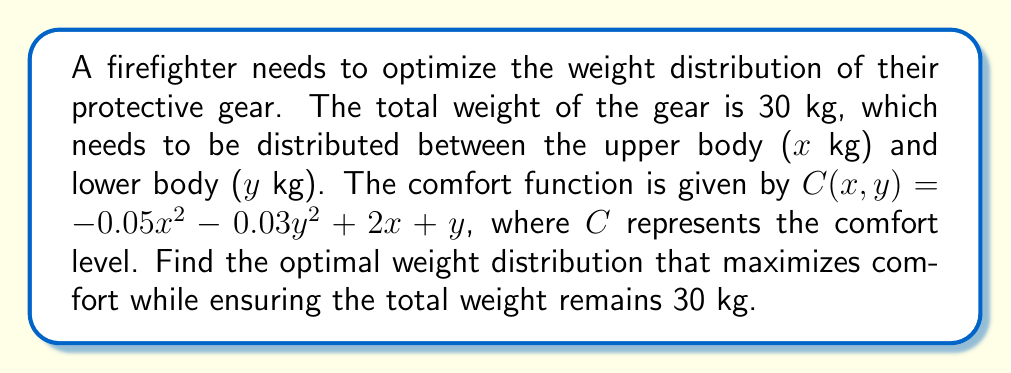Help me with this question. To solve this optimization problem, we'll use the method of Lagrange multipliers:

1) First, we set up the Lagrangian function:
   $$L(x,y,\lambda) = -0.05x^2 - 0.03y^2 + 2x + y + \lambda(30 - x - y)$$

2) Now, we take partial derivatives and set them equal to zero:
   $$\frac{\partial L}{\partial x} = -0.1x + 2 - \lambda = 0$$
   $$\frac{\partial L}{\partial y} = -0.06y + 1 - \lambda = 0$$
   $$\frac{\partial L}{\partial \lambda} = 30 - x - y = 0$$

3) From the first equation:
   $$\lambda = 2 - 0.1x$$

4) From the second equation:
   $$\lambda = 1 - 0.06y$$

5) Equating these:
   $$2 - 0.1x = 1 - 0.06y$$
   $$1 = 0.1x - 0.06y$$
   $$10 = x - 0.6y$$

6) Substituting this into the constraint equation:
   $$30 - (10 + 0.6y) - y = 0$$
   $$20 - 1.6y = 0$$
   $$y = 12.5$$

7) Substituting back:
   $$x = 10 + 0.6(12.5) = 17.5$$

8) We can verify this is a maximum by checking the second derivatives:
   $$\frac{\partial^2 C}{\partial x^2} = -0.1 < 0$$
   $$\frac{\partial^2 C}{\partial y^2} = -0.06 < 0$$

   The negative second derivatives confirm this is indeed a maximum.
Answer: The optimal weight distribution is 17.5 kg for the upper body and 12.5 kg for the lower body. 